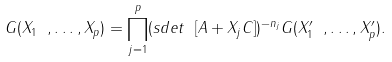<formula> <loc_0><loc_0><loc_500><loc_500>G ( X _ { 1 } \ , \dots , X _ { p } ) = \prod _ { j = 1 } ^ { p } ( s d e t \ [ A + X _ { j } C ] ) ^ { - n _ { j } } G ( X _ { 1 } ^ { \prime } \ , \dots , X _ { p } ^ { \prime } ) .</formula> 